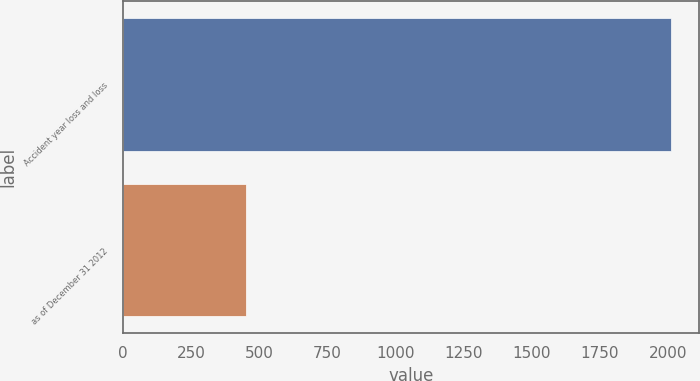Convert chart to OTSL. <chart><loc_0><loc_0><loc_500><loc_500><bar_chart><fcel>Accident year loss and loss<fcel>as of December 31 2012<nl><fcel>2011<fcel>450<nl></chart> 